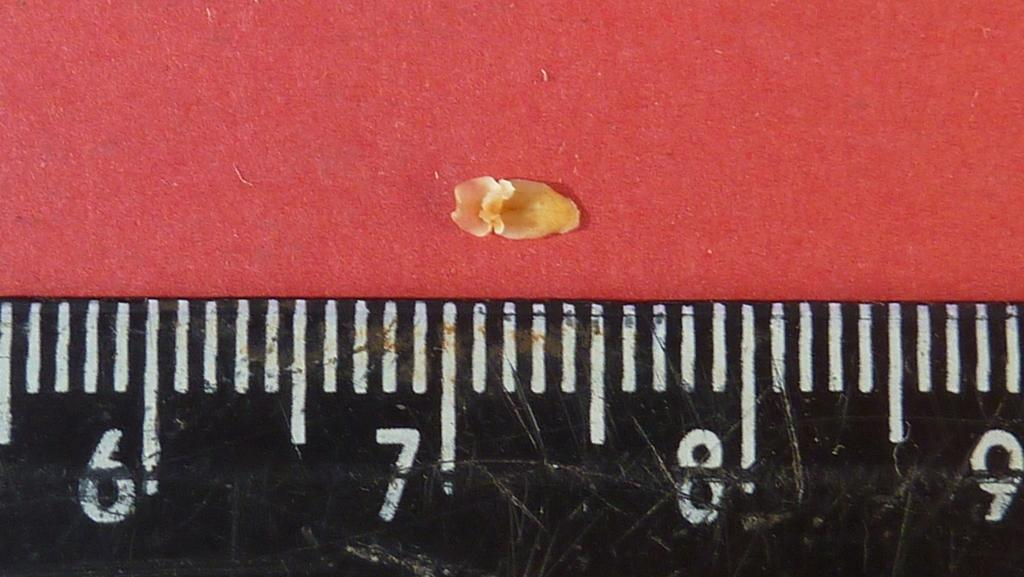Provide a one-sentence caption for the provided image. a ruler with numbers 6-9 measure a yellow kernal. 